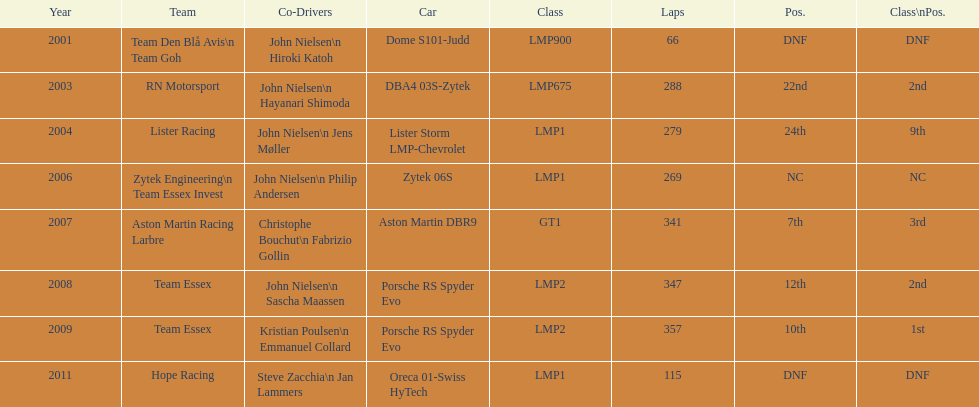How many times was the porsche rs spyder used in competition? 2. 